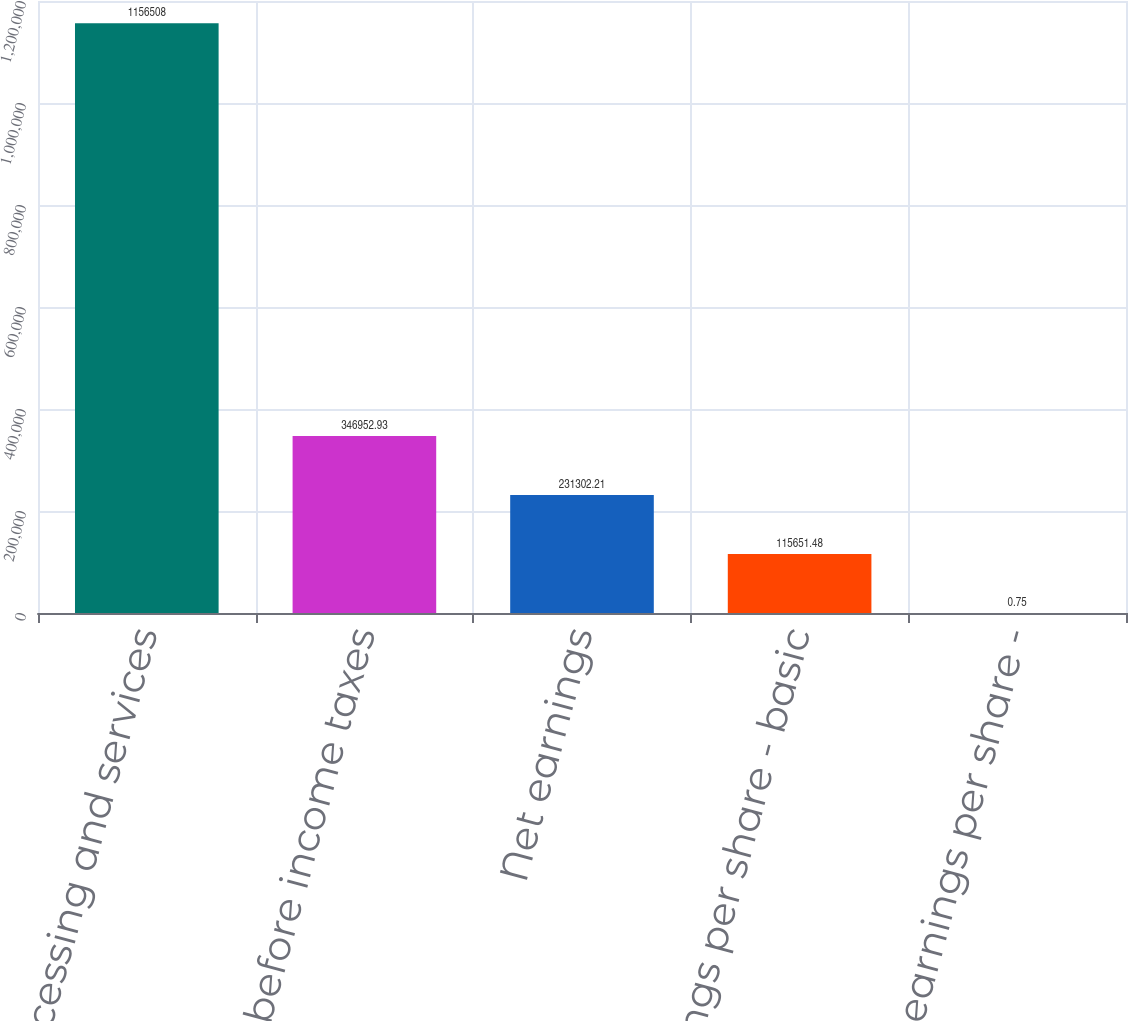Convert chart to OTSL. <chart><loc_0><loc_0><loc_500><loc_500><bar_chart><fcel>Processing and services<fcel>Earnings before income taxes<fcel>Net earnings<fcel>Net earnings per share - basic<fcel>Net earnings per share -<nl><fcel>1.15651e+06<fcel>346953<fcel>231302<fcel>115651<fcel>0.75<nl></chart> 